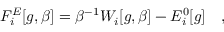<formula> <loc_0><loc_0><loc_500><loc_500>F _ { i } ^ { E } [ g , \beta ] = \beta ^ { - 1 } W _ { i } [ g , \beta ] - E _ { i } ^ { 0 } [ g ] ,</formula> 